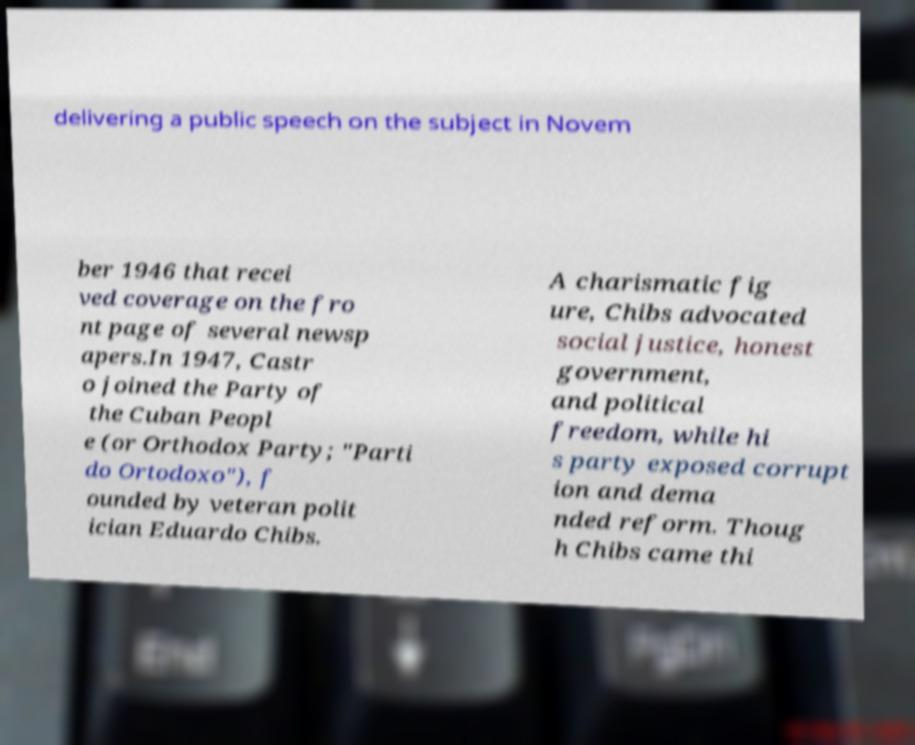What messages or text are displayed in this image? I need them in a readable, typed format. delivering a public speech on the subject in Novem ber 1946 that recei ved coverage on the fro nt page of several newsp apers.In 1947, Castr o joined the Party of the Cuban Peopl e (or Orthodox Party; "Parti do Ortodoxo"), f ounded by veteran polit ician Eduardo Chibs. A charismatic fig ure, Chibs advocated social justice, honest government, and political freedom, while hi s party exposed corrupt ion and dema nded reform. Thoug h Chibs came thi 